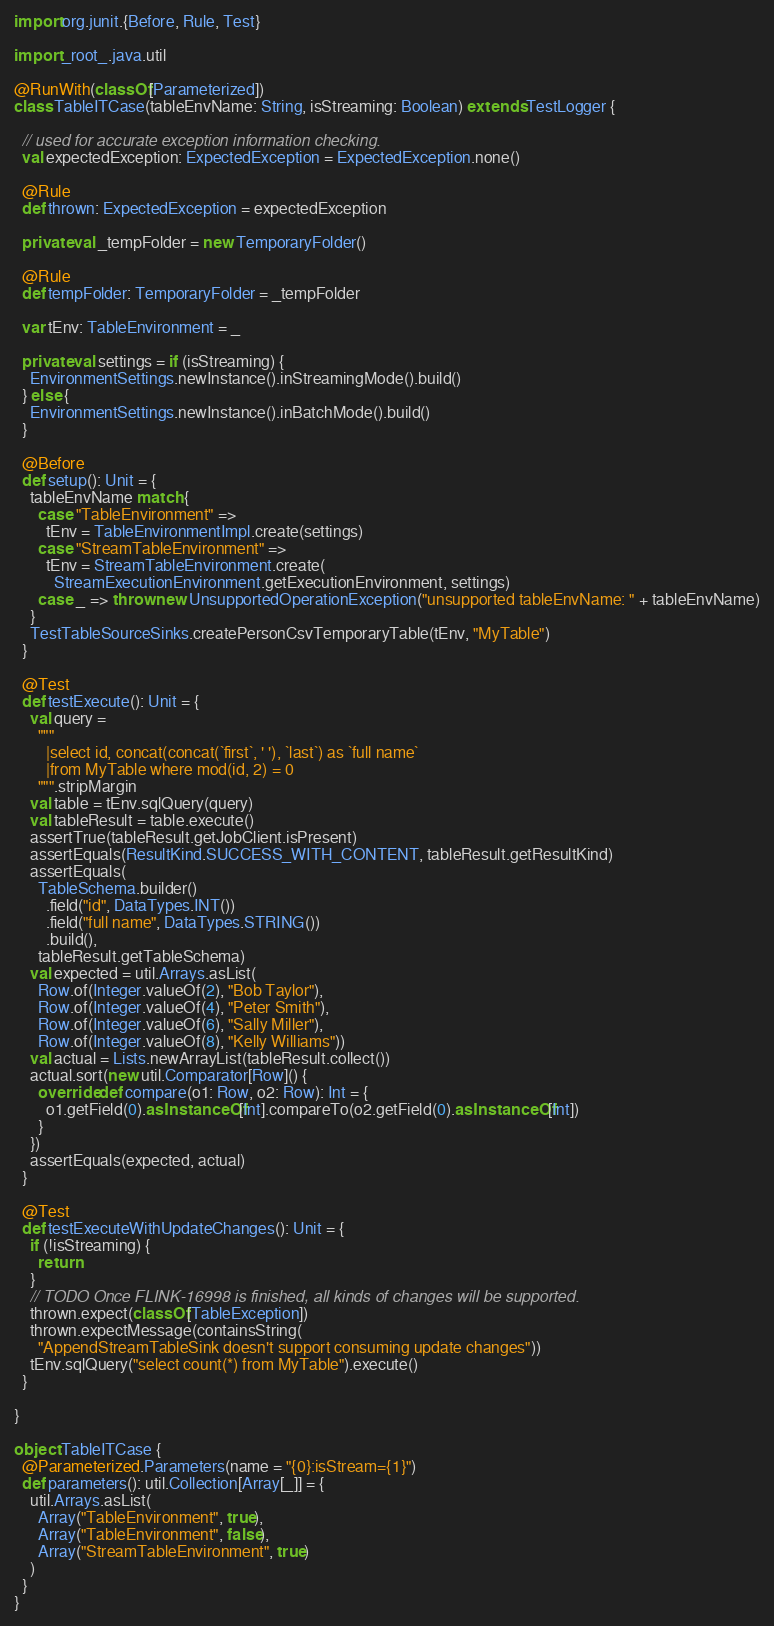Convert code to text. <code><loc_0><loc_0><loc_500><loc_500><_Scala_>import org.junit.{Before, Rule, Test}

import _root_.java.util

@RunWith(classOf[Parameterized])
class TableITCase(tableEnvName: String, isStreaming: Boolean) extends TestLogger {

  // used for accurate exception information checking.
  val expectedException: ExpectedException = ExpectedException.none()

  @Rule
  def thrown: ExpectedException = expectedException

  private val _tempFolder = new TemporaryFolder()

  @Rule
  def tempFolder: TemporaryFolder = _tempFolder

  var tEnv: TableEnvironment = _

  private val settings = if (isStreaming) {
    EnvironmentSettings.newInstance().inStreamingMode().build()
  } else {
    EnvironmentSettings.newInstance().inBatchMode().build()
  }

  @Before
  def setup(): Unit = {
    tableEnvName match {
      case "TableEnvironment" =>
        tEnv = TableEnvironmentImpl.create(settings)
      case "StreamTableEnvironment" =>
        tEnv = StreamTableEnvironment.create(
          StreamExecutionEnvironment.getExecutionEnvironment, settings)
      case _ => throw new UnsupportedOperationException("unsupported tableEnvName: " + tableEnvName)
    }
    TestTableSourceSinks.createPersonCsvTemporaryTable(tEnv, "MyTable")
  }

  @Test
  def testExecute(): Unit = {
    val query =
      """
        |select id, concat(concat(`first`, ' '), `last`) as `full name`
        |from MyTable where mod(id, 2) = 0
      """.stripMargin
    val table = tEnv.sqlQuery(query)
    val tableResult = table.execute()
    assertTrue(tableResult.getJobClient.isPresent)
    assertEquals(ResultKind.SUCCESS_WITH_CONTENT, tableResult.getResultKind)
    assertEquals(
      TableSchema.builder()
        .field("id", DataTypes.INT())
        .field("full name", DataTypes.STRING())
        .build(),
      tableResult.getTableSchema)
    val expected = util.Arrays.asList(
      Row.of(Integer.valueOf(2), "Bob Taylor"),
      Row.of(Integer.valueOf(4), "Peter Smith"),
      Row.of(Integer.valueOf(6), "Sally Miller"),
      Row.of(Integer.valueOf(8), "Kelly Williams"))
    val actual = Lists.newArrayList(tableResult.collect())
    actual.sort(new util.Comparator[Row]() {
      override def compare(o1: Row, o2: Row): Int = {
        o1.getField(0).asInstanceOf[Int].compareTo(o2.getField(0).asInstanceOf[Int])
      }
    })
    assertEquals(expected, actual)
  }

  @Test
  def testExecuteWithUpdateChanges(): Unit = {
    if (!isStreaming) {
      return
    }
    // TODO Once FLINK-16998 is finished, all kinds of changes will be supported.
    thrown.expect(classOf[TableException])
    thrown.expectMessage(containsString(
      "AppendStreamTableSink doesn't support consuming update changes"))
    tEnv.sqlQuery("select count(*) from MyTable").execute()
  }

}

object TableITCase {
  @Parameterized.Parameters(name = "{0}:isStream={1}")
  def parameters(): util.Collection[Array[_]] = {
    util.Arrays.asList(
      Array("TableEnvironment", true),
      Array("TableEnvironment", false),
      Array("StreamTableEnvironment", true)
    )
  }
}
</code> 